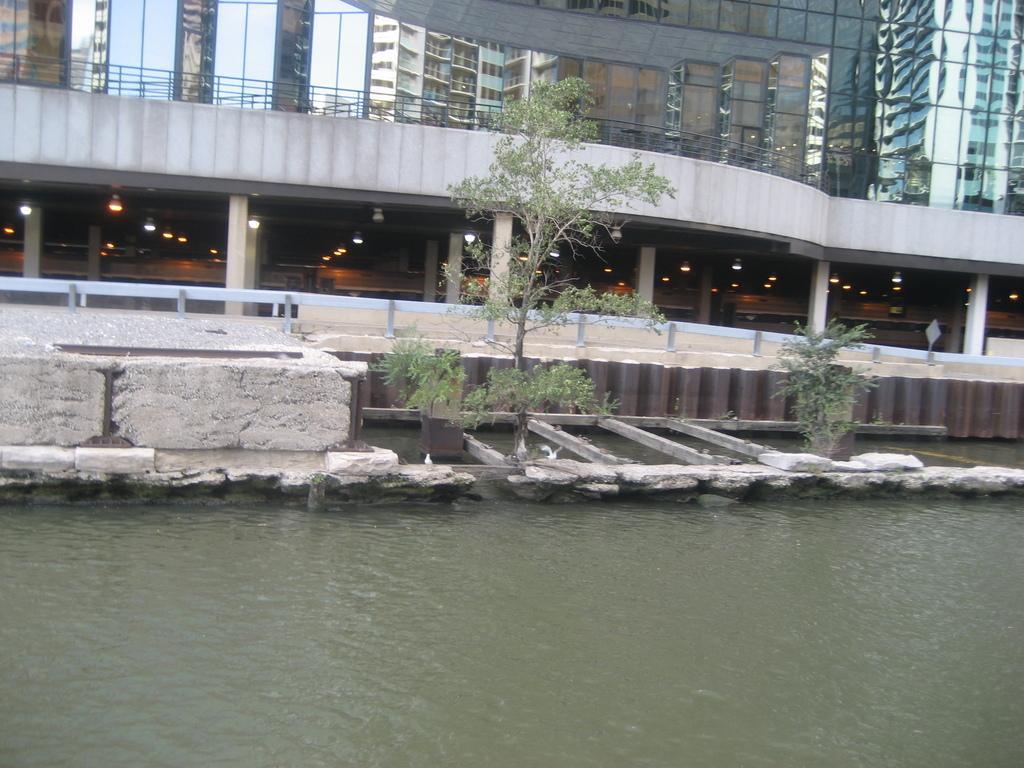Can you describe this image briefly? In this image, we can see water and we can see some buildings. 